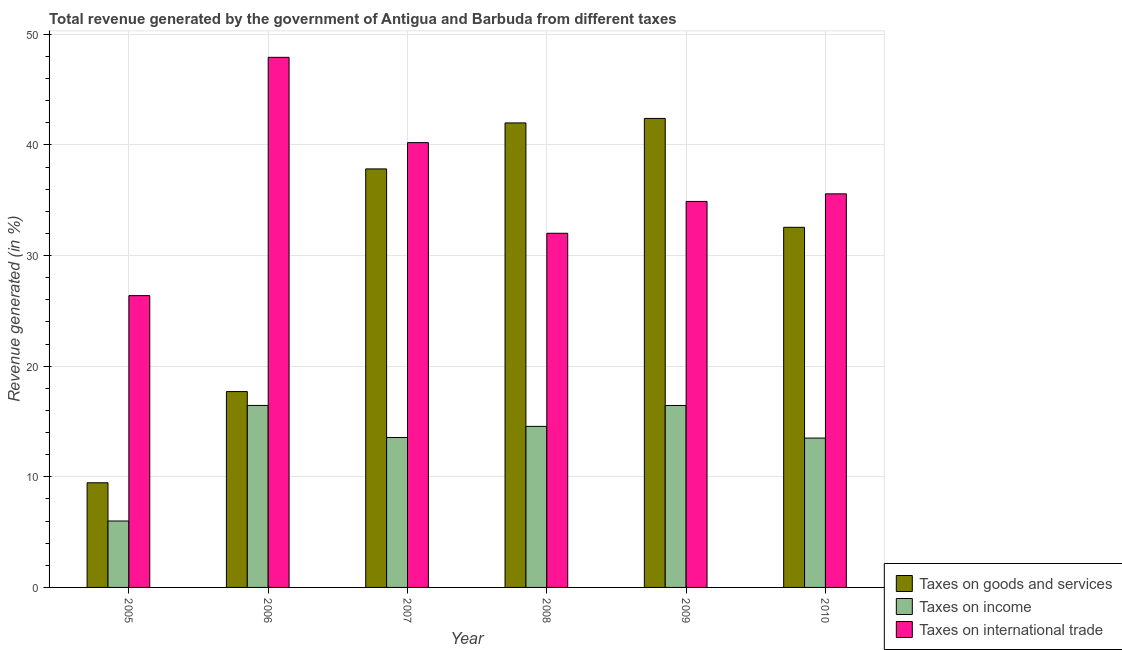Are the number of bars per tick equal to the number of legend labels?
Your response must be concise. Yes. Are the number of bars on each tick of the X-axis equal?
Give a very brief answer. Yes. How many bars are there on the 4th tick from the left?
Provide a succinct answer. 3. In how many cases, is the number of bars for a given year not equal to the number of legend labels?
Give a very brief answer. 0. What is the percentage of revenue generated by taxes on income in 2006?
Keep it short and to the point. 16.45. Across all years, what is the maximum percentage of revenue generated by taxes on income?
Provide a short and direct response. 16.45. Across all years, what is the minimum percentage of revenue generated by taxes on goods and services?
Your response must be concise. 9.46. In which year was the percentage of revenue generated by tax on international trade maximum?
Your answer should be compact. 2006. What is the total percentage of revenue generated by tax on international trade in the graph?
Your response must be concise. 216.96. What is the difference between the percentage of revenue generated by taxes on income in 2007 and that in 2010?
Offer a terse response. 0.05. What is the difference between the percentage of revenue generated by taxes on goods and services in 2006 and the percentage of revenue generated by tax on international trade in 2009?
Provide a succinct answer. -24.69. What is the average percentage of revenue generated by taxes on income per year?
Your response must be concise. 13.42. In how many years, is the percentage of revenue generated by tax on international trade greater than 6 %?
Your answer should be compact. 6. What is the ratio of the percentage of revenue generated by tax on international trade in 2005 to that in 2010?
Provide a succinct answer. 0.74. What is the difference between the highest and the second highest percentage of revenue generated by tax on international trade?
Provide a short and direct response. 7.71. What is the difference between the highest and the lowest percentage of revenue generated by taxes on goods and services?
Offer a terse response. 32.93. What does the 1st bar from the left in 2007 represents?
Your response must be concise. Taxes on goods and services. What does the 3rd bar from the right in 2007 represents?
Provide a succinct answer. Taxes on goods and services. Is it the case that in every year, the sum of the percentage of revenue generated by taxes on goods and services and percentage of revenue generated by taxes on income is greater than the percentage of revenue generated by tax on international trade?
Your response must be concise. No. How many bars are there?
Give a very brief answer. 18. How many years are there in the graph?
Ensure brevity in your answer.  6. What is the difference between two consecutive major ticks on the Y-axis?
Your answer should be compact. 10. Are the values on the major ticks of Y-axis written in scientific E-notation?
Give a very brief answer. No. Where does the legend appear in the graph?
Make the answer very short. Bottom right. How many legend labels are there?
Your response must be concise. 3. How are the legend labels stacked?
Offer a terse response. Vertical. What is the title of the graph?
Your response must be concise. Total revenue generated by the government of Antigua and Barbuda from different taxes. Does "Domestic" appear as one of the legend labels in the graph?
Give a very brief answer. No. What is the label or title of the X-axis?
Keep it short and to the point. Year. What is the label or title of the Y-axis?
Give a very brief answer. Revenue generated (in %). What is the Revenue generated (in %) of Taxes on goods and services in 2005?
Provide a succinct answer. 9.46. What is the Revenue generated (in %) in Taxes on income in 2005?
Keep it short and to the point. 6.01. What is the Revenue generated (in %) in Taxes on international trade in 2005?
Your answer should be compact. 26.37. What is the Revenue generated (in %) of Taxes on goods and services in 2006?
Offer a very short reply. 17.7. What is the Revenue generated (in %) in Taxes on income in 2006?
Your answer should be compact. 16.45. What is the Revenue generated (in %) of Taxes on international trade in 2006?
Provide a short and direct response. 47.91. What is the Revenue generated (in %) of Taxes on goods and services in 2007?
Your answer should be compact. 37.83. What is the Revenue generated (in %) of Taxes on income in 2007?
Offer a very short reply. 13.55. What is the Revenue generated (in %) of Taxes on international trade in 2007?
Offer a terse response. 40.2. What is the Revenue generated (in %) of Taxes on goods and services in 2008?
Provide a succinct answer. 41.98. What is the Revenue generated (in %) in Taxes on income in 2008?
Provide a succinct answer. 14.56. What is the Revenue generated (in %) of Taxes on international trade in 2008?
Make the answer very short. 32.01. What is the Revenue generated (in %) in Taxes on goods and services in 2009?
Keep it short and to the point. 42.39. What is the Revenue generated (in %) in Taxes on income in 2009?
Your answer should be very brief. 16.45. What is the Revenue generated (in %) of Taxes on international trade in 2009?
Give a very brief answer. 34.89. What is the Revenue generated (in %) of Taxes on goods and services in 2010?
Ensure brevity in your answer.  32.55. What is the Revenue generated (in %) of Taxes on income in 2010?
Offer a terse response. 13.5. What is the Revenue generated (in %) in Taxes on international trade in 2010?
Provide a short and direct response. 35.57. Across all years, what is the maximum Revenue generated (in %) in Taxes on goods and services?
Offer a very short reply. 42.39. Across all years, what is the maximum Revenue generated (in %) in Taxes on income?
Keep it short and to the point. 16.45. Across all years, what is the maximum Revenue generated (in %) in Taxes on international trade?
Give a very brief answer. 47.91. Across all years, what is the minimum Revenue generated (in %) of Taxes on goods and services?
Offer a terse response. 9.46. Across all years, what is the minimum Revenue generated (in %) of Taxes on income?
Provide a succinct answer. 6.01. Across all years, what is the minimum Revenue generated (in %) of Taxes on international trade?
Offer a very short reply. 26.37. What is the total Revenue generated (in %) of Taxes on goods and services in the graph?
Keep it short and to the point. 181.91. What is the total Revenue generated (in %) of Taxes on income in the graph?
Your response must be concise. 80.5. What is the total Revenue generated (in %) in Taxes on international trade in the graph?
Provide a succinct answer. 216.96. What is the difference between the Revenue generated (in %) of Taxes on goods and services in 2005 and that in 2006?
Your answer should be compact. -8.24. What is the difference between the Revenue generated (in %) of Taxes on income in 2005 and that in 2006?
Offer a terse response. -10.44. What is the difference between the Revenue generated (in %) of Taxes on international trade in 2005 and that in 2006?
Make the answer very short. -21.54. What is the difference between the Revenue generated (in %) in Taxes on goods and services in 2005 and that in 2007?
Give a very brief answer. -28.37. What is the difference between the Revenue generated (in %) of Taxes on income in 2005 and that in 2007?
Offer a terse response. -7.54. What is the difference between the Revenue generated (in %) of Taxes on international trade in 2005 and that in 2007?
Provide a short and direct response. -13.83. What is the difference between the Revenue generated (in %) of Taxes on goods and services in 2005 and that in 2008?
Offer a terse response. -32.52. What is the difference between the Revenue generated (in %) of Taxes on income in 2005 and that in 2008?
Offer a terse response. -8.55. What is the difference between the Revenue generated (in %) in Taxes on international trade in 2005 and that in 2008?
Provide a short and direct response. -5.64. What is the difference between the Revenue generated (in %) of Taxes on goods and services in 2005 and that in 2009?
Your answer should be very brief. -32.93. What is the difference between the Revenue generated (in %) of Taxes on income in 2005 and that in 2009?
Give a very brief answer. -10.44. What is the difference between the Revenue generated (in %) of Taxes on international trade in 2005 and that in 2009?
Offer a very short reply. -8.51. What is the difference between the Revenue generated (in %) of Taxes on goods and services in 2005 and that in 2010?
Your answer should be compact. -23.09. What is the difference between the Revenue generated (in %) of Taxes on income in 2005 and that in 2010?
Keep it short and to the point. -7.49. What is the difference between the Revenue generated (in %) of Taxes on international trade in 2005 and that in 2010?
Provide a short and direct response. -9.2. What is the difference between the Revenue generated (in %) of Taxes on goods and services in 2006 and that in 2007?
Make the answer very short. -20.13. What is the difference between the Revenue generated (in %) of Taxes on income in 2006 and that in 2007?
Offer a very short reply. 2.9. What is the difference between the Revenue generated (in %) of Taxes on international trade in 2006 and that in 2007?
Ensure brevity in your answer.  7.71. What is the difference between the Revenue generated (in %) of Taxes on goods and services in 2006 and that in 2008?
Ensure brevity in your answer.  -24.28. What is the difference between the Revenue generated (in %) of Taxes on income in 2006 and that in 2008?
Provide a short and direct response. 1.89. What is the difference between the Revenue generated (in %) of Taxes on international trade in 2006 and that in 2008?
Your response must be concise. 15.9. What is the difference between the Revenue generated (in %) in Taxes on goods and services in 2006 and that in 2009?
Provide a succinct answer. -24.69. What is the difference between the Revenue generated (in %) in Taxes on income in 2006 and that in 2009?
Ensure brevity in your answer.  0. What is the difference between the Revenue generated (in %) in Taxes on international trade in 2006 and that in 2009?
Provide a succinct answer. 13.02. What is the difference between the Revenue generated (in %) in Taxes on goods and services in 2006 and that in 2010?
Your answer should be very brief. -14.85. What is the difference between the Revenue generated (in %) in Taxes on income in 2006 and that in 2010?
Offer a very short reply. 2.95. What is the difference between the Revenue generated (in %) of Taxes on international trade in 2006 and that in 2010?
Offer a terse response. 12.34. What is the difference between the Revenue generated (in %) in Taxes on goods and services in 2007 and that in 2008?
Provide a short and direct response. -4.16. What is the difference between the Revenue generated (in %) of Taxes on income in 2007 and that in 2008?
Your response must be concise. -1.01. What is the difference between the Revenue generated (in %) of Taxes on international trade in 2007 and that in 2008?
Your answer should be compact. 8.19. What is the difference between the Revenue generated (in %) in Taxes on goods and services in 2007 and that in 2009?
Offer a terse response. -4.56. What is the difference between the Revenue generated (in %) of Taxes on income in 2007 and that in 2009?
Provide a short and direct response. -2.9. What is the difference between the Revenue generated (in %) of Taxes on international trade in 2007 and that in 2009?
Offer a terse response. 5.32. What is the difference between the Revenue generated (in %) of Taxes on goods and services in 2007 and that in 2010?
Your response must be concise. 5.28. What is the difference between the Revenue generated (in %) of Taxes on income in 2007 and that in 2010?
Your answer should be very brief. 0.05. What is the difference between the Revenue generated (in %) of Taxes on international trade in 2007 and that in 2010?
Offer a terse response. 4.63. What is the difference between the Revenue generated (in %) of Taxes on goods and services in 2008 and that in 2009?
Your response must be concise. -0.41. What is the difference between the Revenue generated (in %) in Taxes on income in 2008 and that in 2009?
Your answer should be very brief. -1.89. What is the difference between the Revenue generated (in %) of Taxes on international trade in 2008 and that in 2009?
Your answer should be compact. -2.88. What is the difference between the Revenue generated (in %) in Taxes on goods and services in 2008 and that in 2010?
Make the answer very short. 9.44. What is the difference between the Revenue generated (in %) in Taxes on income in 2008 and that in 2010?
Your answer should be very brief. 1.06. What is the difference between the Revenue generated (in %) in Taxes on international trade in 2008 and that in 2010?
Your answer should be compact. -3.56. What is the difference between the Revenue generated (in %) of Taxes on goods and services in 2009 and that in 2010?
Your answer should be compact. 9.84. What is the difference between the Revenue generated (in %) in Taxes on income in 2009 and that in 2010?
Provide a short and direct response. 2.95. What is the difference between the Revenue generated (in %) in Taxes on international trade in 2009 and that in 2010?
Ensure brevity in your answer.  -0.69. What is the difference between the Revenue generated (in %) of Taxes on goods and services in 2005 and the Revenue generated (in %) of Taxes on income in 2006?
Your answer should be compact. -6.99. What is the difference between the Revenue generated (in %) in Taxes on goods and services in 2005 and the Revenue generated (in %) in Taxes on international trade in 2006?
Offer a terse response. -38.45. What is the difference between the Revenue generated (in %) of Taxes on income in 2005 and the Revenue generated (in %) of Taxes on international trade in 2006?
Your response must be concise. -41.91. What is the difference between the Revenue generated (in %) of Taxes on goods and services in 2005 and the Revenue generated (in %) of Taxes on income in 2007?
Keep it short and to the point. -4.09. What is the difference between the Revenue generated (in %) of Taxes on goods and services in 2005 and the Revenue generated (in %) of Taxes on international trade in 2007?
Provide a succinct answer. -30.74. What is the difference between the Revenue generated (in %) of Taxes on income in 2005 and the Revenue generated (in %) of Taxes on international trade in 2007?
Keep it short and to the point. -34.2. What is the difference between the Revenue generated (in %) in Taxes on goods and services in 2005 and the Revenue generated (in %) in Taxes on income in 2008?
Give a very brief answer. -5.1. What is the difference between the Revenue generated (in %) in Taxes on goods and services in 2005 and the Revenue generated (in %) in Taxes on international trade in 2008?
Your answer should be compact. -22.55. What is the difference between the Revenue generated (in %) in Taxes on income in 2005 and the Revenue generated (in %) in Taxes on international trade in 2008?
Give a very brief answer. -26.01. What is the difference between the Revenue generated (in %) in Taxes on goods and services in 2005 and the Revenue generated (in %) in Taxes on income in 2009?
Offer a terse response. -6.99. What is the difference between the Revenue generated (in %) of Taxes on goods and services in 2005 and the Revenue generated (in %) of Taxes on international trade in 2009?
Offer a very short reply. -25.43. What is the difference between the Revenue generated (in %) in Taxes on income in 2005 and the Revenue generated (in %) in Taxes on international trade in 2009?
Offer a very short reply. -28.88. What is the difference between the Revenue generated (in %) in Taxes on goods and services in 2005 and the Revenue generated (in %) in Taxes on income in 2010?
Your response must be concise. -4.04. What is the difference between the Revenue generated (in %) in Taxes on goods and services in 2005 and the Revenue generated (in %) in Taxes on international trade in 2010?
Offer a terse response. -26.11. What is the difference between the Revenue generated (in %) in Taxes on income in 2005 and the Revenue generated (in %) in Taxes on international trade in 2010?
Give a very brief answer. -29.57. What is the difference between the Revenue generated (in %) in Taxes on goods and services in 2006 and the Revenue generated (in %) in Taxes on income in 2007?
Provide a succinct answer. 4.15. What is the difference between the Revenue generated (in %) of Taxes on goods and services in 2006 and the Revenue generated (in %) of Taxes on international trade in 2007?
Provide a succinct answer. -22.5. What is the difference between the Revenue generated (in %) in Taxes on income in 2006 and the Revenue generated (in %) in Taxes on international trade in 2007?
Offer a very short reply. -23.76. What is the difference between the Revenue generated (in %) of Taxes on goods and services in 2006 and the Revenue generated (in %) of Taxes on income in 2008?
Your answer should be compact. 3.15. What is the difference between the Revenue generated (in %) in Taxes on goods and services in 2006 and the Revenue generated (in %) in Taxes on international trade in 2008?
Offer a very short reply. -14.31. What is the difference between the Revenue generated (in %) in Taxes on income in 2006 and the Revenue generated (in %) in Taxes on international trade in 2008?
Offer a very short reply. -15.56. What is the difference between the Revenue generated (in %) of Taxes on goods and services in 2006 and the Revenue generated (in %) of Taxes on income in 2009?
Your answer should be compact. 1.26. What is the difference between the Revenue generated (in %) in Taxes on goods and services in 2006 and the Revenue generated (in %) in Taxes on international trade in 2009?
Your answer should be compact. -17.19. What is the difference between the Revenue generated (in %) of Taxes on income in 2006 and the Revenue generated (in %) of Taxes on international trade in 2009?
Provide a short and direct response. -18.44. What is the difference between the Revenue generated (in %) in Taxes on goods and services in 2006 and the Revenue generated (in %) in Taxes on income in 2010?
Give a very brief answer. 4.2. What is the difference between the Revenue generated (in %) of Taxes on goods and services in 2006 and the Revenue generated (in %) of Taxes on international trade in 2010?
Provide a succinct answer. -17.87. What is the difference between the Revenue generated (in %) of Taxes on income in 2006 and the Revenue generated (in %) of Taxes on international trade in 2010?
Provide a succinct answer. -19.13. What is the difference between the Revenue generated (in %) in Taxes on goods and services in 2007 and the Revenue generated (in %) in Taxes on income in 2008?
Provide a short and direct response. 23.27. What is the difference between the Revenue generated (in %) of Taxes on goods and services in 2007 and the Revenue generated (in %) of Taxes on international trade in 2008?
Keep it short and to the point. 5.82. What is the difference between the Revenue generated (in %) of Taxes on income in 2007 and the Revenue generated (in %) of Taxes on international trade in 2008?
Provide a succinct answer. -18.46. What is the difference between the Revenue generated (in %) of Taxes on goods and services in 2007 and the Revenue generated (in %) of Taxes on income in 2009?
Give a very brief answer. 21.38. What is the difference between the Revenue generated (in %) of Taxes on goods and services in 2007 and the Revenue generated (in %) of Taxes on international trade in 2009?
Give a very brief answer. 2.94. What is the difference between the Revenue generated (in %) in Taxes on income in 2007 and the Revenue generated (in %) in Taxes on international trade in 2009?
Ensure brevity in your answer.  -21.34. What is the difference between the Revenue generated (in %) in Taxes on goods and services in 2007 and the Revenue generated (in %) in Taxes on income in 2010?
Make the answer very short. 24.33. What is the difference between the Revenue generated (in %) of Taxes on goods and services in 2007 and the Revenue generated (in %) of Taxes on international trade in 2010?
Offer a very short reply. 2.25. What is the difference between the Revenue generated (in %) of Taxes on income in 2007 and the Revenue generated (in %) of Taxes on international trade in 2010?
Keep it short and to the point. -22.02. What is the difference between the Revenue generated (in %) of Taxes on goods and services in 2008 and the Revenue generated (in %) of Taxes on income in 2009?
Your answer should be compact. 25.54. What is the difference between the Revenue generated (in %) in Taxes on goods and services in 2008 and the Revenue generated (in %) in Taxes on international trade in 2009?
Give a very brief answer. 7.1. What is the difference between the Revenue generated (in %) in Taxes on income in 2008 and the Revenue generated (in %) in Taxes on international trade in 2009?
Offer a terse response. -20.33. What is the difference between the Revenue generated (in %) of Taxes on goods and services in 2008 and the Revenue generated (in %) of Taxes on income in 2010?
Keep it short and to the point. 28.49. What is the difference between the Revenue generated (in %) of Taxes on goods and services in 2008 and the Revenue generated (in %) of Taxes on international trade in 2010?
Keep it short and to the point. 6.41. What is the difference between the Revenue generated (in %) in Taxes on income in 2008 and the Revenue generated (in %) in Taxes on international trade in 2010?
Provide a short and direct response. -21.02. What is the difference between the Revenue generated (in %) in Taxes on goods and services in 2009 and the Revenue generated (in %) in Taxes on income in 2010?
Provide a succinct answer. 28.89. What is the difference between the Revenue generated (in %) of Taxes on goods and services in 2009 and the Revenue generated (in %) of Taxes on international trade in 2010?
Provide a short and direct response. 6.82. What is the difference between the Revenue generated (in %) of Taxes on income in 2009 and the Revenue generated (in %) of Taxes on international trade in 2010?
Offer a terse response. -19.13. What is the average Revenue generated (in %) in Taxes on goods and services per year?
Keep it short and to the point. 30.32. What is the average Revenue generated (in %) in Taxes on income per year?
Keep it short and to the point. 13.42. What is the average Revenue generated (in %) of Taxes on international trade per year?
Keep it short and to the point. 36.16. In the year 2005, what is the difference between the Revenue generated (in %) in Taxes on goods and services and Revenue generated (in %) in Taxes on income?
Offer a very short reply. 3.45. In the year 2005, what is the difference between the Revenue generated (in %) in Taxes on goods and services and Revenue generated (in %) in Taxes on international trade?
Your answer should be compact. -16.91. In the year 2005, what is the difference between the Revenue generated (in %) of Taxes on income and Revenue generated (in %) of Taxes on international trade?
Your answer should be compact. -20.37. In the year 2006, what is the difference between the Revenue generated (in %) in Taxes on goods and services and Revenue generated (in %) in Taxes on income?
Your answer should be compact. 1.25. In the year 2006, what is the difference between the Revenue generated (in %) of Taxes on goods and services and Revenue generated (in %) of Taxes on international trade?
Offer a very short reply. -30.21. In the year 2006, what is the difference between the Revenue generated (in %) of Taxes on income and Revenue generated (in %) of Taxes on international trade?
Keep it short and to the point. -31.46. In the year 2007, what is the difference between the Revenue generated (in %) of Taxes on goods and services and Revenue generated (in %) of Taxes on income?
Ensure brevity in your answer.  24.28. In the year 2007, what is the difference between the Revenue generated (in %) in Taxes on goods and services and Revenue generated (in %) in Taxes on international trade?
Keep it short and to the point. -2.38. In the year 2007, what is the difference between the Revenue generated (in %) in Taxes on income and Revenue generated (in %) in Taxes on international trade?
Your response must be concise. -26.66. In the year 2008, what is the difference between the Revenue generated (in %) in Taxes on goods and services and Revenue generated (in %) in Taxes on income?
Your answer should be compact. 27.43. In the year 2008, what is the difference between the Revenue generated (in %) in Taxes on goods and services and Revenue generated (in %) in Taxes on international trade?
Your answer should be very brief. 9.97. In the year 2008, what is the difference between the Revenue generated (in %) in Taxes on income and Revenue generated (in %) in Taxes on international trade?
Give a very brief answer. -17.45. In the year 2009, what is the difference between the Revenue generated (in %) of Taxes on goods and services and Revenue generated (in %) of Taxes on income?
Give a very brief answer. 25.94. In the year 2009, what is the difference between the Revenue generated (in %) in Taxes on goods and services and Revenue generated (in %) in Taxes on international trade?
Ensure brevity in your answer.  7.5. In the year 2009, what is the difference between the Revenue generated (in %) of Taxes on income and Revenue generated (in %) of Taxes on international trade?
Your answer should be compact. -18.44. In the year 2010, what is the difference between the Revenue generated (in %) of Taxes on goods and services and Revenue generated (in %) of Taxes on income?
Give a very brief answer. 19.05. In the year 2010, what is the difference between the Revenue generated (in %) of Taxes on goods and services and Revenue generated (in %) of Taxes on international trade?
Offer a terse response. -3.02. In the year 2010, what is the difference between the Revenue generated (in %) of Taxes on income and Revenue generated (in %) of Taxes on international trade?
Make the answer very short. -22.07. What is the ratio of the Revenue generated (in %) in Taxes on goods and services in 2005 to that in 2006?
Keep it short and to the point. 0.53. What is the ratio of the Revenue generated (in %) in Taxes on income in 2005 to that in 2006?
Provide a short and direct response. 0.37. What is the ratio of the Revenue generated (in %) in Taxes on international trade in 2005 to that in 2006?
Your response must be concise. 0.55. What is the ratio of the Revenue generated (in %) of Taxes on goods and services in 2005 to that in 2007?
Give a very brief answer. 0.25. What is the ratio of the Revenue generated (in %) in Taxes on income in 2005 to that in 2007?
Provide a short and direct response. 0.44. What is the ratio of the Revenue generated (in %) in Taxes on international trade in 2005 to that in 2007?
Ensure brevity in your answer.  0.66. What is the ratio of the Revenue generated (in %) of Taxes on goods and services in 2005 to that in 2008?
Give a very brief answer. 0.23. What is the ratio of the Revenue generated (in %) in Taxes on income in 2005 to that in 2008?
Your answer should be compact. 0.41. What is the ratio of the Revenue generated (in %) of Taxes on international trade in 2005 to that in 2008?
Your answer should be compact. 0.82. What is the ratio of the Revenue generated (in %) in Taxes on goods and services in 2005 to that in 2009?
Your answer should be compact. 0.22. What is the ratio of the Revenue generated (in %) in Taxes on income in 2005 to that in 2009?
Keep it short and to the point. 0.37. What is the ratio of the Revenue generated (in %) in Taxes on international trade in 2005 to that in 2009?
Offer a very short reply. 0.76. What is the ratio of the Revenue generated (in %) of Taxes on goods and services in 2005 to that in 2010?
Your response must be concise. 0.29. What is the ratio of the Revenue generated (in %) of Taxes on income in 2005 to that in 2010?
Your response must be concise. 0.44. What is the ratio of the Revenue generated (in %) of Taxes on international trade in 2005 to that in 2010?
Provide a succinct answer. 0.74. What is the ratio of the Revenue generated (in %) of Taxes on goods and services in 2006 to that in 2007?
Your answer should be compact. 0.47. What is the ratio of the Revenue generated (in %) of Taxes on income in 2006 to that in 2007?
Keep it short and to the point. 1.21. What is the ratio of the Revenue generated (in %) in Taxes on international trade in 2006 to that in 2007?
Give a very brief answer. 1.19. What is the ratio of the Revenue generated (in %) in Taxes on goods and services in 2006 to that in 2008?
Keep it short and to the point. 0.42. What is the ratio of the Revenue generated (in %) of Taxes on income in 2006 to that in 2008?
Offer a terse response. 1.13. What is the ratio of the Revenue generated (in %) of Taxes on international trade in 2006 to that in 2008?
Provide a short and direct response. 1.5. What is the ratio of the Revenue generated (in %) in Taxes on goods and services in 2006 to that in 2009?
Make the answer very short. 0.42. What is the ratio of the Revenue generated (in %) in Taxes on international trade in 2006 to that in 2009?
Provide a succinct answer. 1.37. What is the ratio of the Revenue generated (in %) of Taxes on goods and services in 2006 to that in 2010?
Your answer should be compact. 0.54. What is the ratio of the Revenue generated (in %) in Taxes on income in 2006 to that in 2010?
Offer a terse response. 1.22. What is the ratio of the Revenue generated (in %) of Taxes on international trade in 2006 to that in 2010?
Keep it short and to the point. 1.35. What is the ratio of the Revenue generated (in %) in Taxes on goods and services in 2007 to that in 2008?
Keep it short and to the point. 0.9. What is the ratio of the Revenue generated (in %) in Taxes on income in 2007 to that in 2008?
Provide a short and direct response. 0.93. What is the ratio of the Revenue generated (in %) in Taxes on international trade in 2007 to that in 2008?
Provide a succinct answer. 1.26. What is the ratio of the Revenue generated (in %) of Taxes on goods and services in 2007 to that in 2009?
Your response must be concise. 0.89. What is the ratio of the Revenue generated (in %) in Taxes on income in 2007 to that in 2009?
Provide a short and direct response. 0.82. What is the ratio of the Revenue generated (in %) in Taxes on international trade in 2007 to that in 2009?
Give a very brief answer. 1.15. What is the ratio of the Revenue generated (in %) in Taxes on goods and services in 2007 to that in 2010?
Your answer should be compact. 1.16. What is the ratio of the Revenue generated (in %) in Taxes on income in 2007 to that in 2010?
Offer a terse response. 1. What is the ratio of the Revenue generated (in %) of Taxes on international trade in 2007 to that in 2010?
Provide a succinct answer. 1.13. What is the ratio of the Revenue generated (in %) of Taxes on income in 2008 to that in 2009?
Ensure brevity in your answer.  0.89. What is the ratio of the Revenue generated (in %) in Taxes on international trade in 2008 to that in 2009?
Offer a terse response. 0.92. What is the ratio of the Revenue generated (in %) of Taxes on goods and services in 2008 to that in 2010?
Provide a short and direct response. 1.29. What is the ratio of the Revenue generated (in %) of Taxes on income in 2008 to that in 2010?
Offer a terse response. 1.08. What is the ratio of the Revenue generated (in %) in Taxes on international trade in 2008 to that in 2010?
Your response must be concise. 0.9. What is the ratio of the Revenue generated (in %) in Taxes on goods and services in 2009 to that in 2010?
Your answer should be very brief. 1.3. What is the ratio of the Revenue generated (in %) of Taxes on income in 2009 to that in 2010?
Your answer should be compact. 1.22. What is the ratio of the Revenue generated (in %) of Taxes on international trade in 2009 to that in 2010?
Keep it short and to the point. 0.98. What is the difference between the highest and the second highest Revenue generated (in %) of Taxes on goods and services?
Give a very brief answer. 0.41. What is the difference between the highest and the second highest Revenue generated (in %) in Taxes on income?
Ensure brevity in your answer.  0. What is the difference between the highest and the second highest Revenue generated (in %) in Taxes on international trade?
Make the answer very short. 7.71. What is the difference between the highest and the lowest Revenue generated (in %) in Taxes on goods and services?
Provide a short and direct response. 32.93. What is the difference between the highest and the lowest Revenue generated (in %) in Taxes on income?
Give a very brief answer. 10.44. What is the difference between the highest and the lowest Revenue generated (in %) in Taxes on international trade?
Your response must be concise. 21.54. 